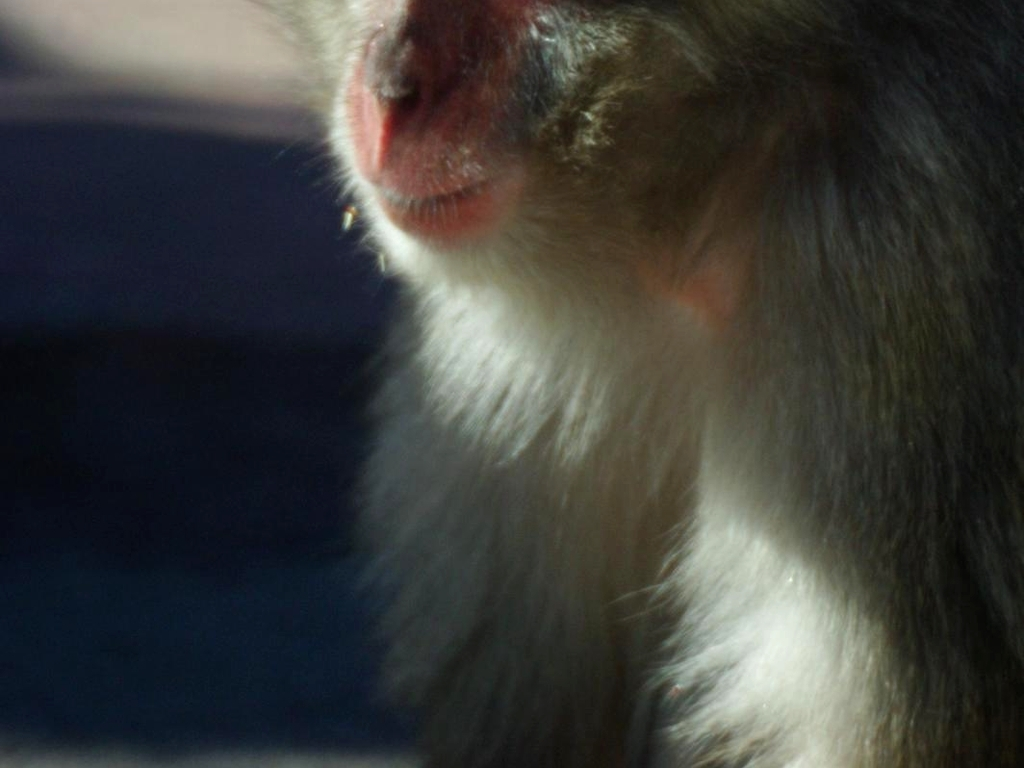What time of day does the lighting in this photo suggest? The warm, diffuse light suggests this photo may have been taken in the late afternoon, during the 'golden hour' before sunset, when the light is often softer and warmer. 